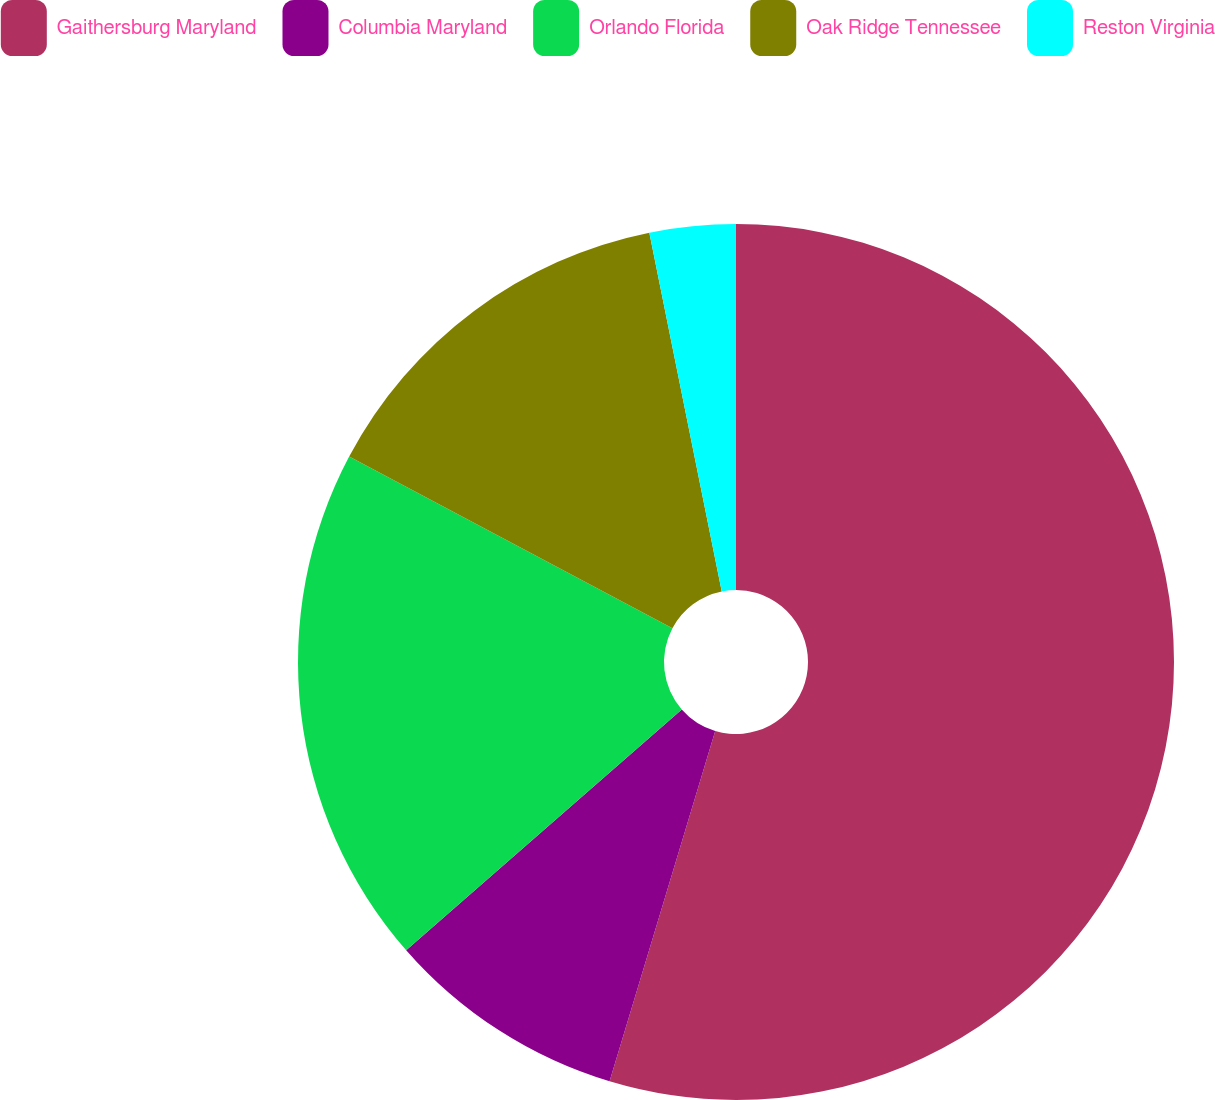<chart> <loc_0><loc_0><loc_500><loc_500><pie_chart><fcel>Gaithersburg Maryland<fcel>Columbia Maryland<fcel>Orlando Florida<fcel>Oak Ridge Tennessee<fcel>Reston Virginia<nl><fcel>54.66%<fcel>8.91%<fcel>19.2%<fcel>14.06%<fcel>3.17%<nl></chart> 